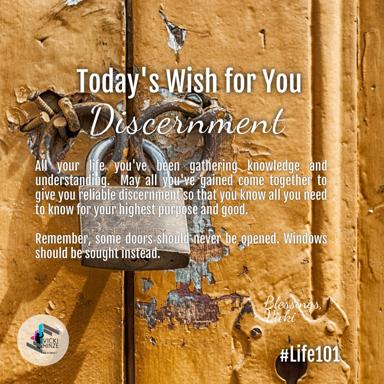What is the wish for today mentioned in the image? The wish for today, as expressed in the image, is for discernment. This concept of discernment represents the cultivated ability to make judicious and wise decisions, especially beneficial after accruing knowledge and experiences over time. 